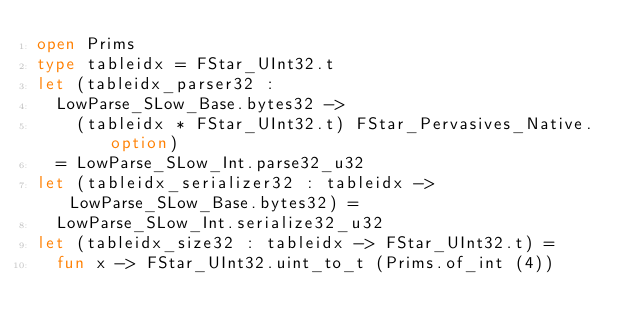<code> <loc_0><loc_0><loc_500><loc_500><_OCaml_>open Prims
type tableidx = FStar_UInt32.t
let (tableidx_parser32 :
  LowParse_SLow_Base.bytes32 ->
    (tableidx * FStar_UInt32.t) FStar_Pervasives_Native.option)
  = LowParse_SLow_Int.parse32_u32
let (tableidx_serializer32 : tableidx -> LowParse_SLow_Base.bytes32) =
  LowParse_SLow_Int.serialize32_u32
let (tableidx_size32 : tableidx -> FStar_UInt32.t) =
  fun x -> FStar_UInt32.uint_to_t (Prims.of_int (4))

</code> 